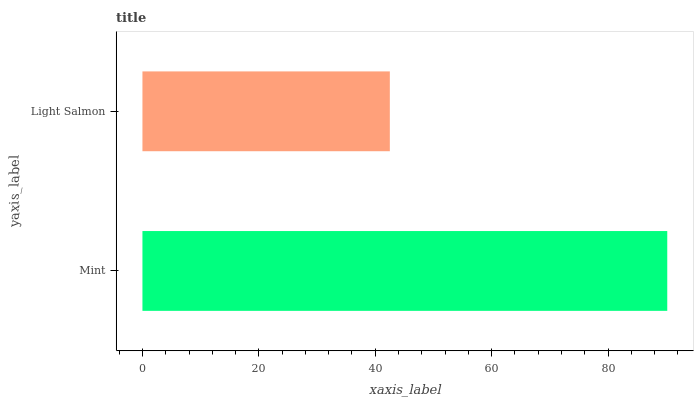Is Light Salmon the minimum?
Answer yes or no. Yes. Is Mint the maximum?
Answer yes or no. Yes. Is Light Salmon the maximum?
Answer yes or no. No. Is Mint greater than Light Salmon?
Answer yes or no. Yes. Is Light Salmon less than Mint?
Answer yes or no. Yes. Is Light Salmon greater than Mint?
Answer yes or no. No. Is Mint less than Light Salmon?
Answer yes or no. No. Is Mint the high median?
Answer yes or no. Yes. Is Light Salmon the low median?
Answer yes or no. Yes. Is Light Salmon the high median?
Answer yes or no. No. Is Mint the low median?
Answer yes or no. No. 